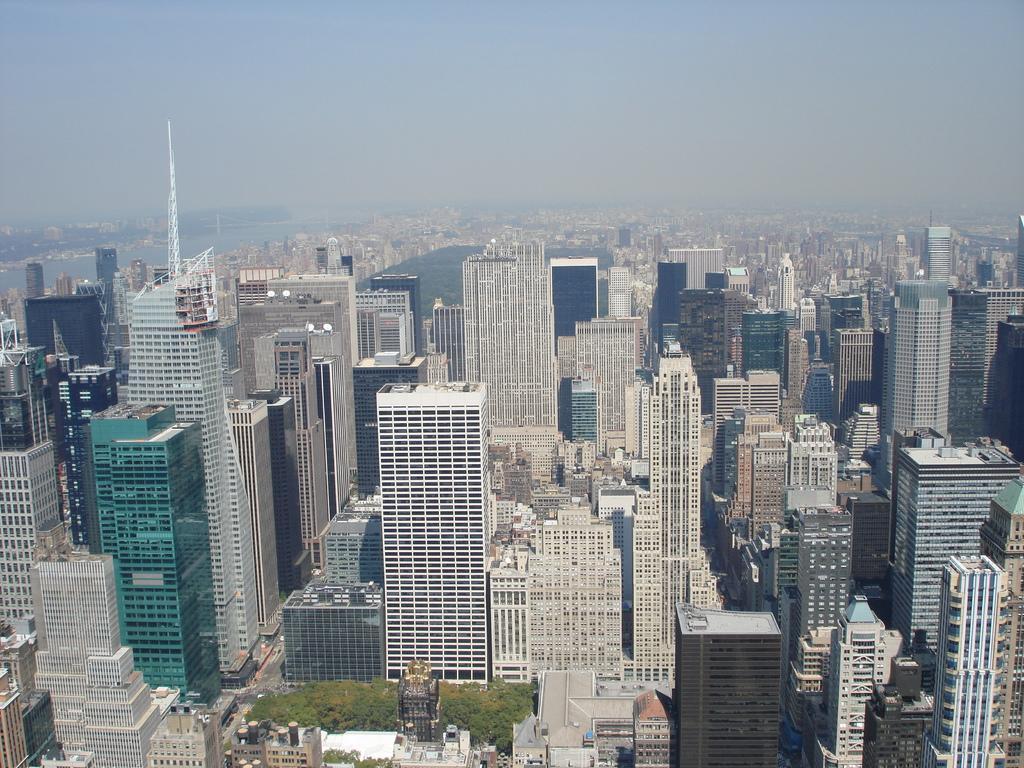Can you describe this image briefly? This picture is clicked outside. In the foreground we can see the buildings and the skyscrapers and we can see the trees and a tower like object. In the background we can see the sky, water body, buildings and many other objects. 